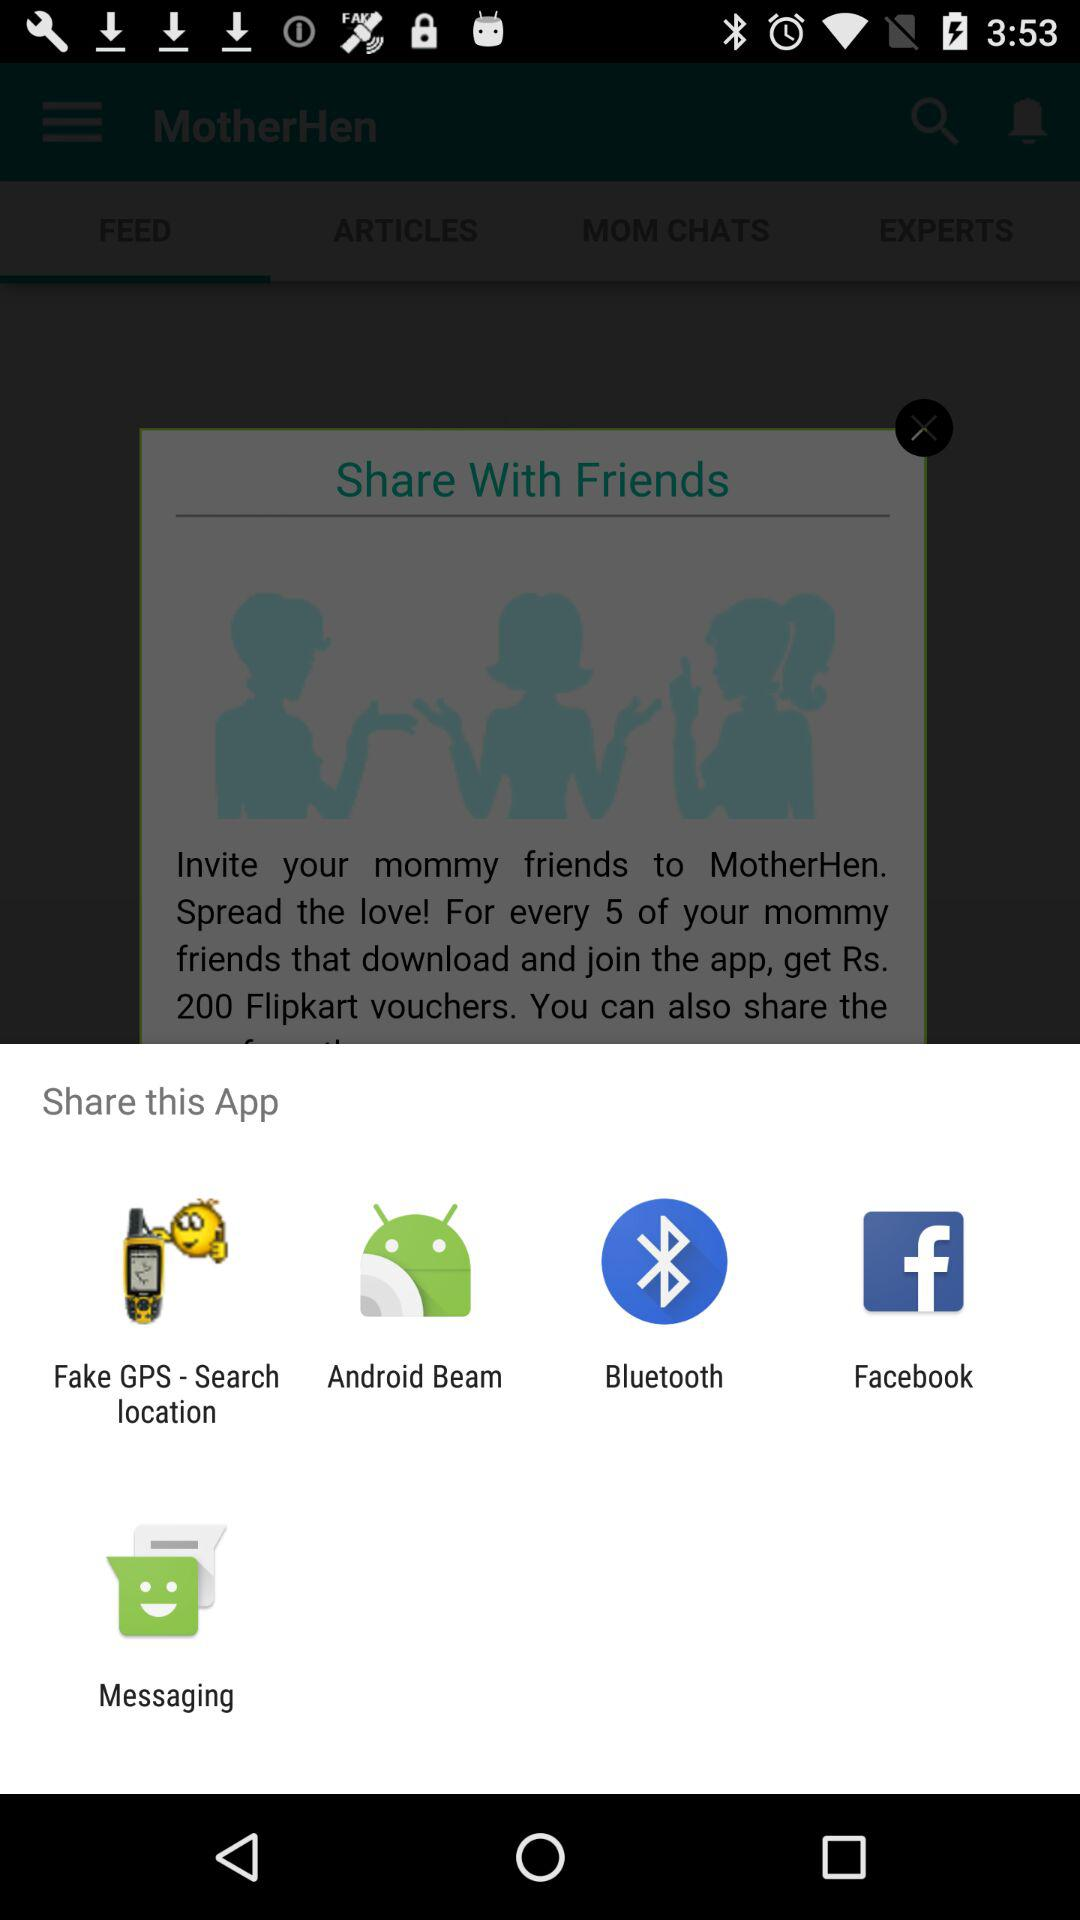Through which applications and mediums can the content be shared? The content can be shared through the "Fake GPS-Search location," "Android Beam," "Bluetooth," "Facebook," and "Messaging" applications and mediums. 